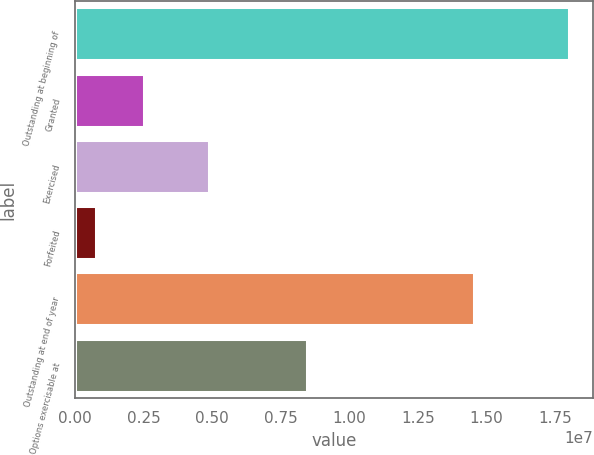<chart> <loc_0><loc_0><loc_500><loc_500><bar_chart><fcel>Outstanding at beginning of<fcel>Granted<fcel>Exercised<fcel>Forfeited<fcel>Outstanding at end of year<fcel>Options exercisable at<nl><fcel>1.79971e+07<fcel>2.49554e+06<fcel>4.87512e+06<fcel>773145<fcel>1.45404e+07<fcel>8.45336e+06<nl></chart> 